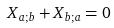<formula> <loc_0><loc_0><loc_500><loc_500>X _ { a ; b } + X _ { b ; a } = 0</formula> 